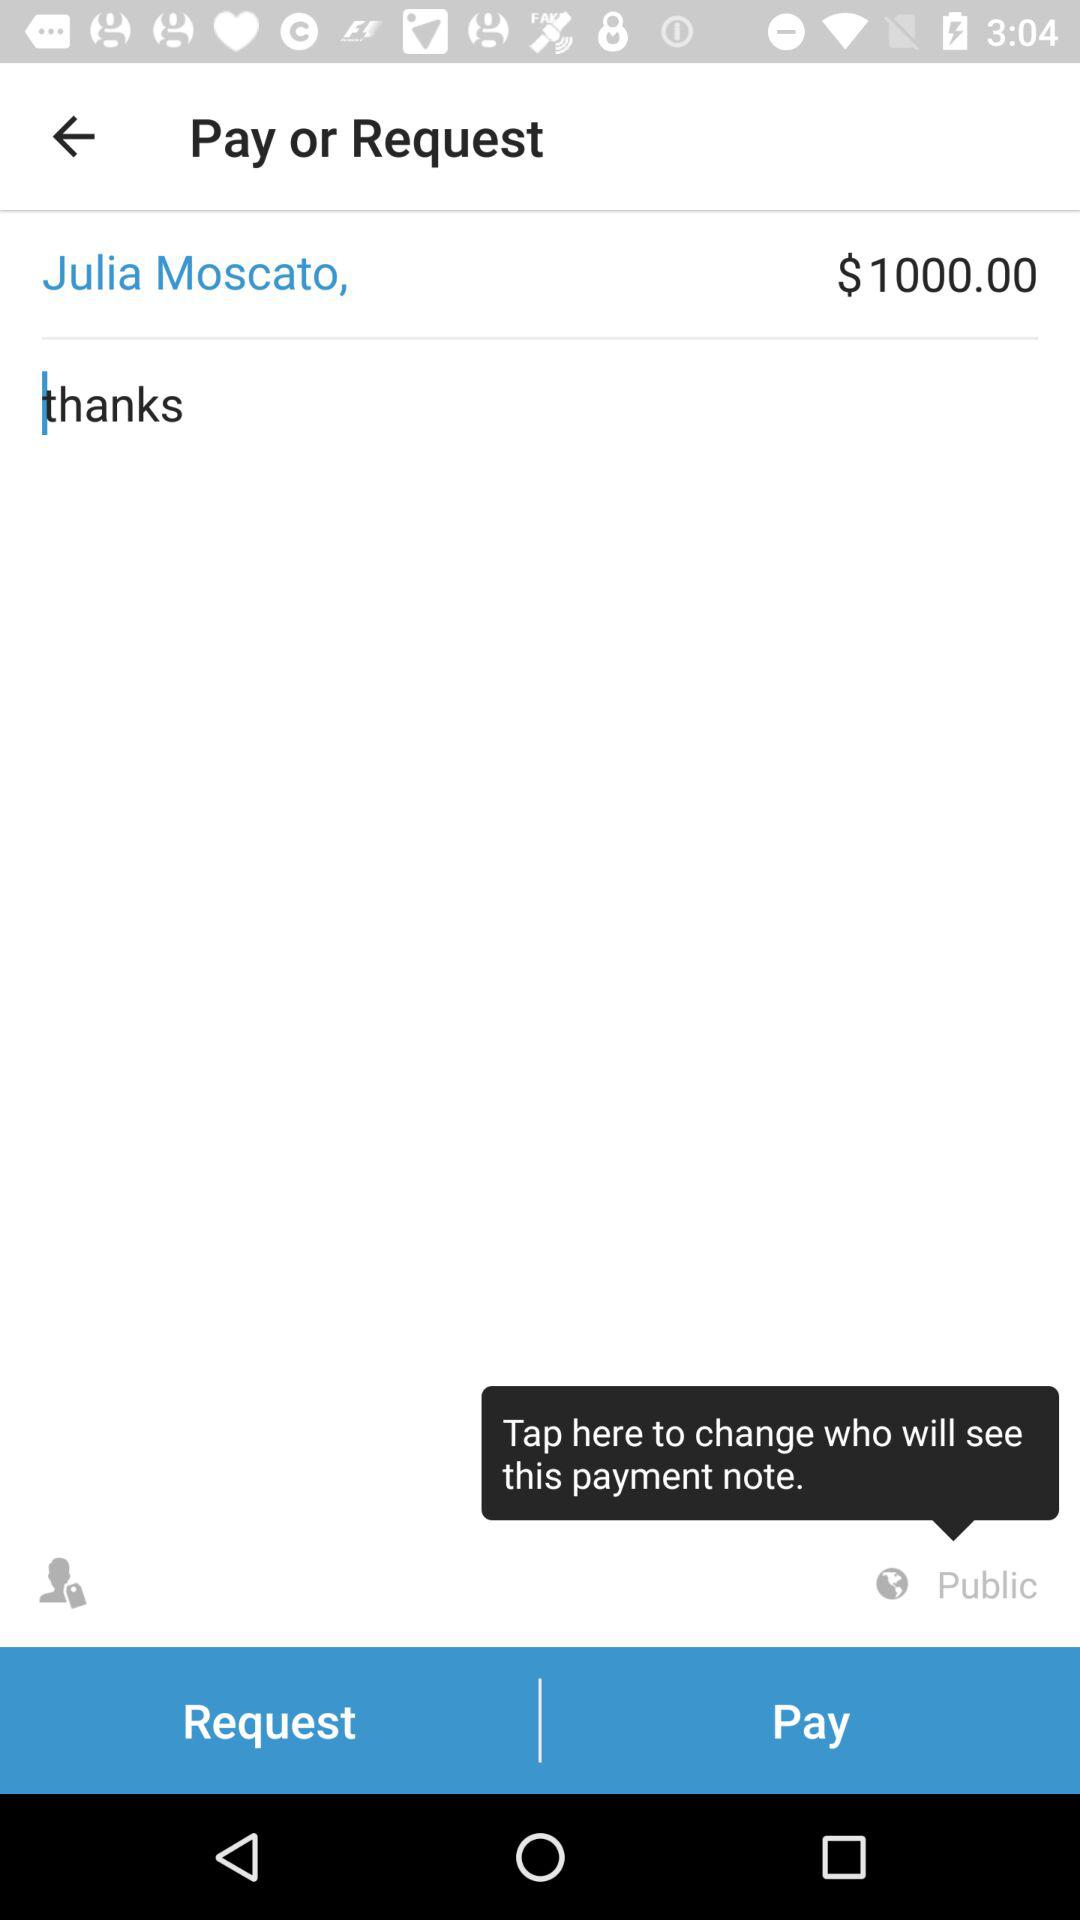How much money has been designated for payment or request to Julia Moscato?
Answer the question using a single word or phrase. It is $1000. 